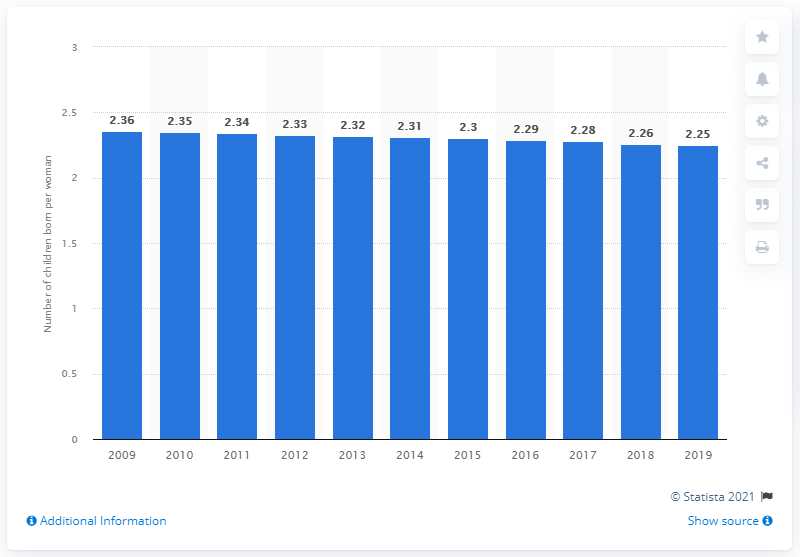List a handful of essential elements in this visual. In 2019, the fertility rate in Argentina was 2.25. 